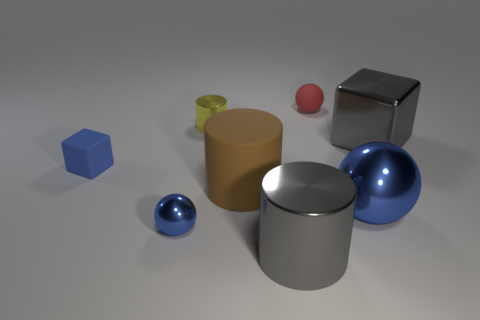Subtract all blue balls. How many balls are left? 1 Subtract all blue cubes. How many cubes are left? 1 Subtract 1 cylinders. How many cylinders are left? 2 Add 1 rubber spheres. How many objects exist? 9 Subtract all blocks. How many objects are left? 6 Subtract all purple spheres. How many blue blocks are left? 1 Add 6 large blue objects. How many large blue objects are left? 7 Add 1 small purple cylinders. How many small purple cylinders exist? 1 Subtract 0 yellow blocks. How many objects are left? 8 Subtract all purple cubes. Subtract all red cylinders. How many cubes are left? 2 